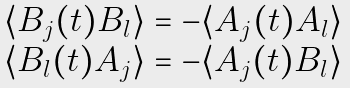Convert formula to latex. <formula><loc_0><loc_0><loc_500><loc_500>\begin{array} { l } \langle B _ { j } ( t ) B _ { l } \rangle = - \langle A _ { j } ( t ) A _ { l } \rangle \\ \langle B _ { l } ( t ) A _ { j } \rangle = - \langle A _ { j } ( t ) B _ { l } \rangle \end{array} \,</formula> 